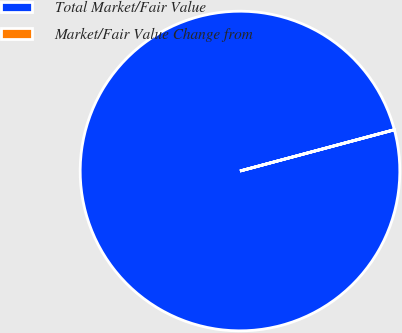<chart> <loc_0><loc_0><loc_500><loc_500><pie_chart><fcel>Total Market/Fair Value<fcel>Market/Fair Value Change from<nl><fcel>99.98%<fcel>0.02%<nl></chart> 